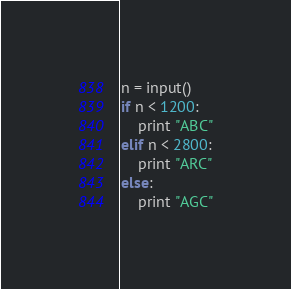Convert code to text. <code><loc_0><loc_0><loc_500><loc_500><_Python_>n = input()
if n < 1200:
    print "ABC"
elif n < 2800:
    print "ARC"
else:
    print "AGC"</code> 